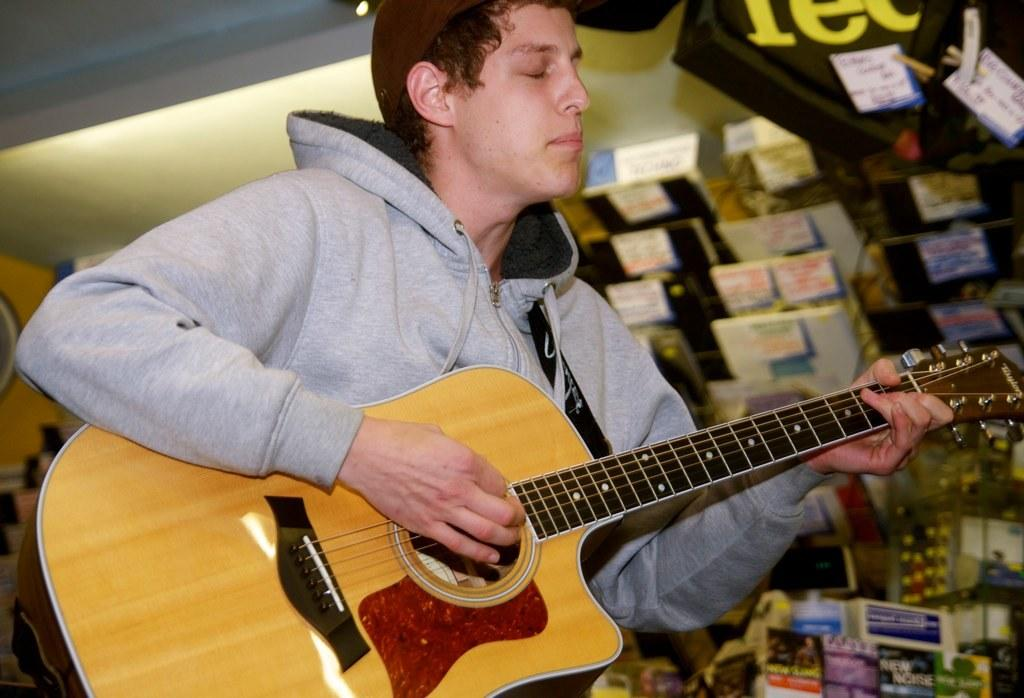What is the main subject of the image? There is a person in the image. What is the person doing in the image? The person is standing and playing the guitar. Are there any other objects or items visible in the image? Yes, there are books visible in the image. What year is the duck born in the image? There is no duck present in the image, so it is not possible to determine the birth year of a duck. 